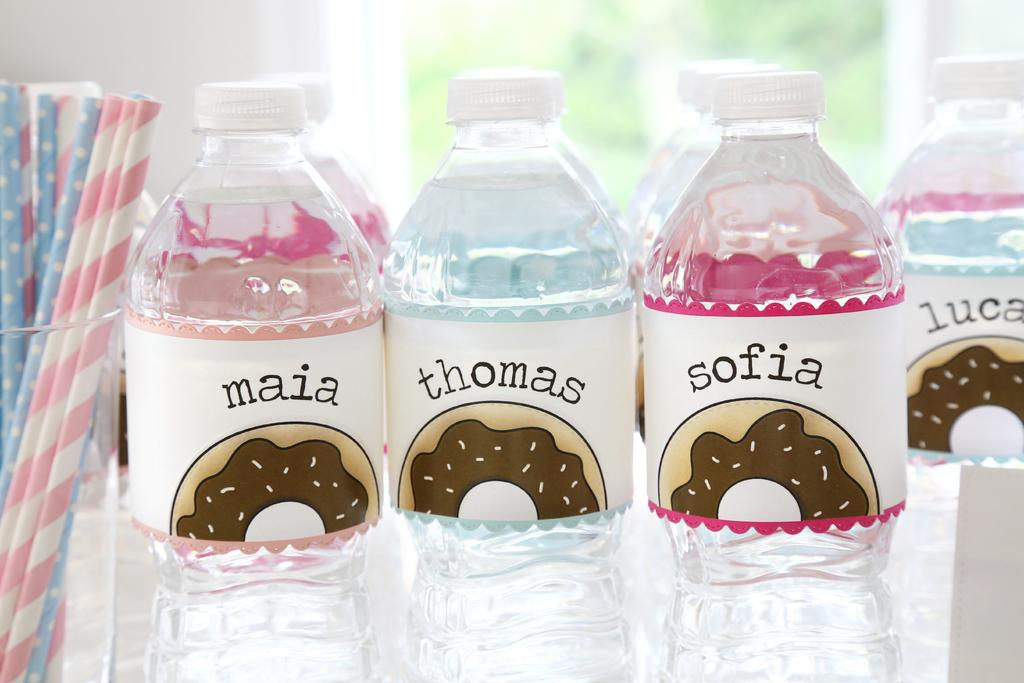What type of beverage containers are visible in the image? There are water bottles in the image. What is inside the glass in the image? There are straws in a glass in the image. What can be seen in the background of the image? There is a wall and a window in the background of the image. How does the current affect the toad in the image? There is no toad or current present in the image. 